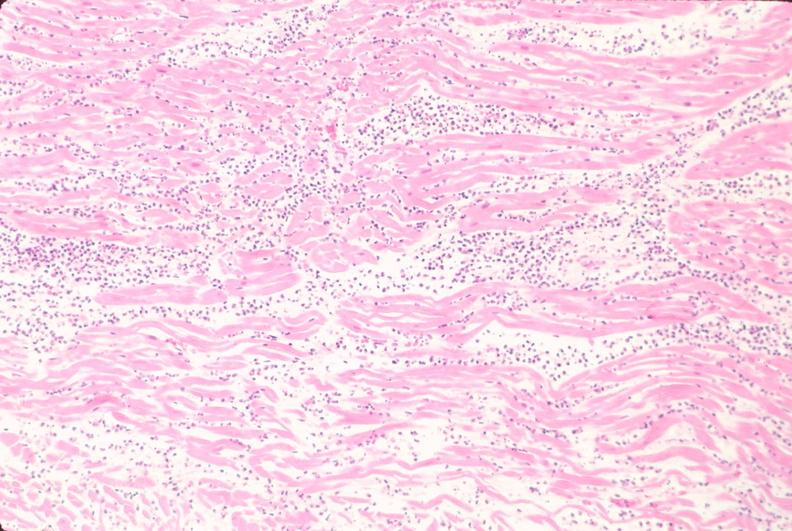s marfans syndrome present?
Answer the question using a single word or phrase. No 